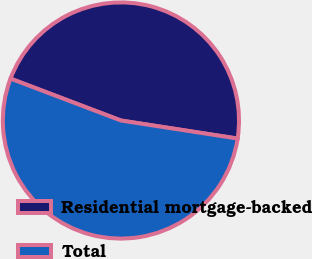Convert chart to OTSL. <chart><loc_0><loc_0><loc_500><loc_500><pie_chart><fcel>Residential mortgage-backed<fcel>Total<nl><fcel>46.67%<fcel>53.33%<nl></chart> 